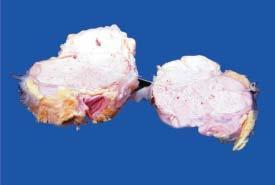re stored iron areas of necrosis in the circumscribed nodular areas?
Answer the question using a single word or phrase. No 